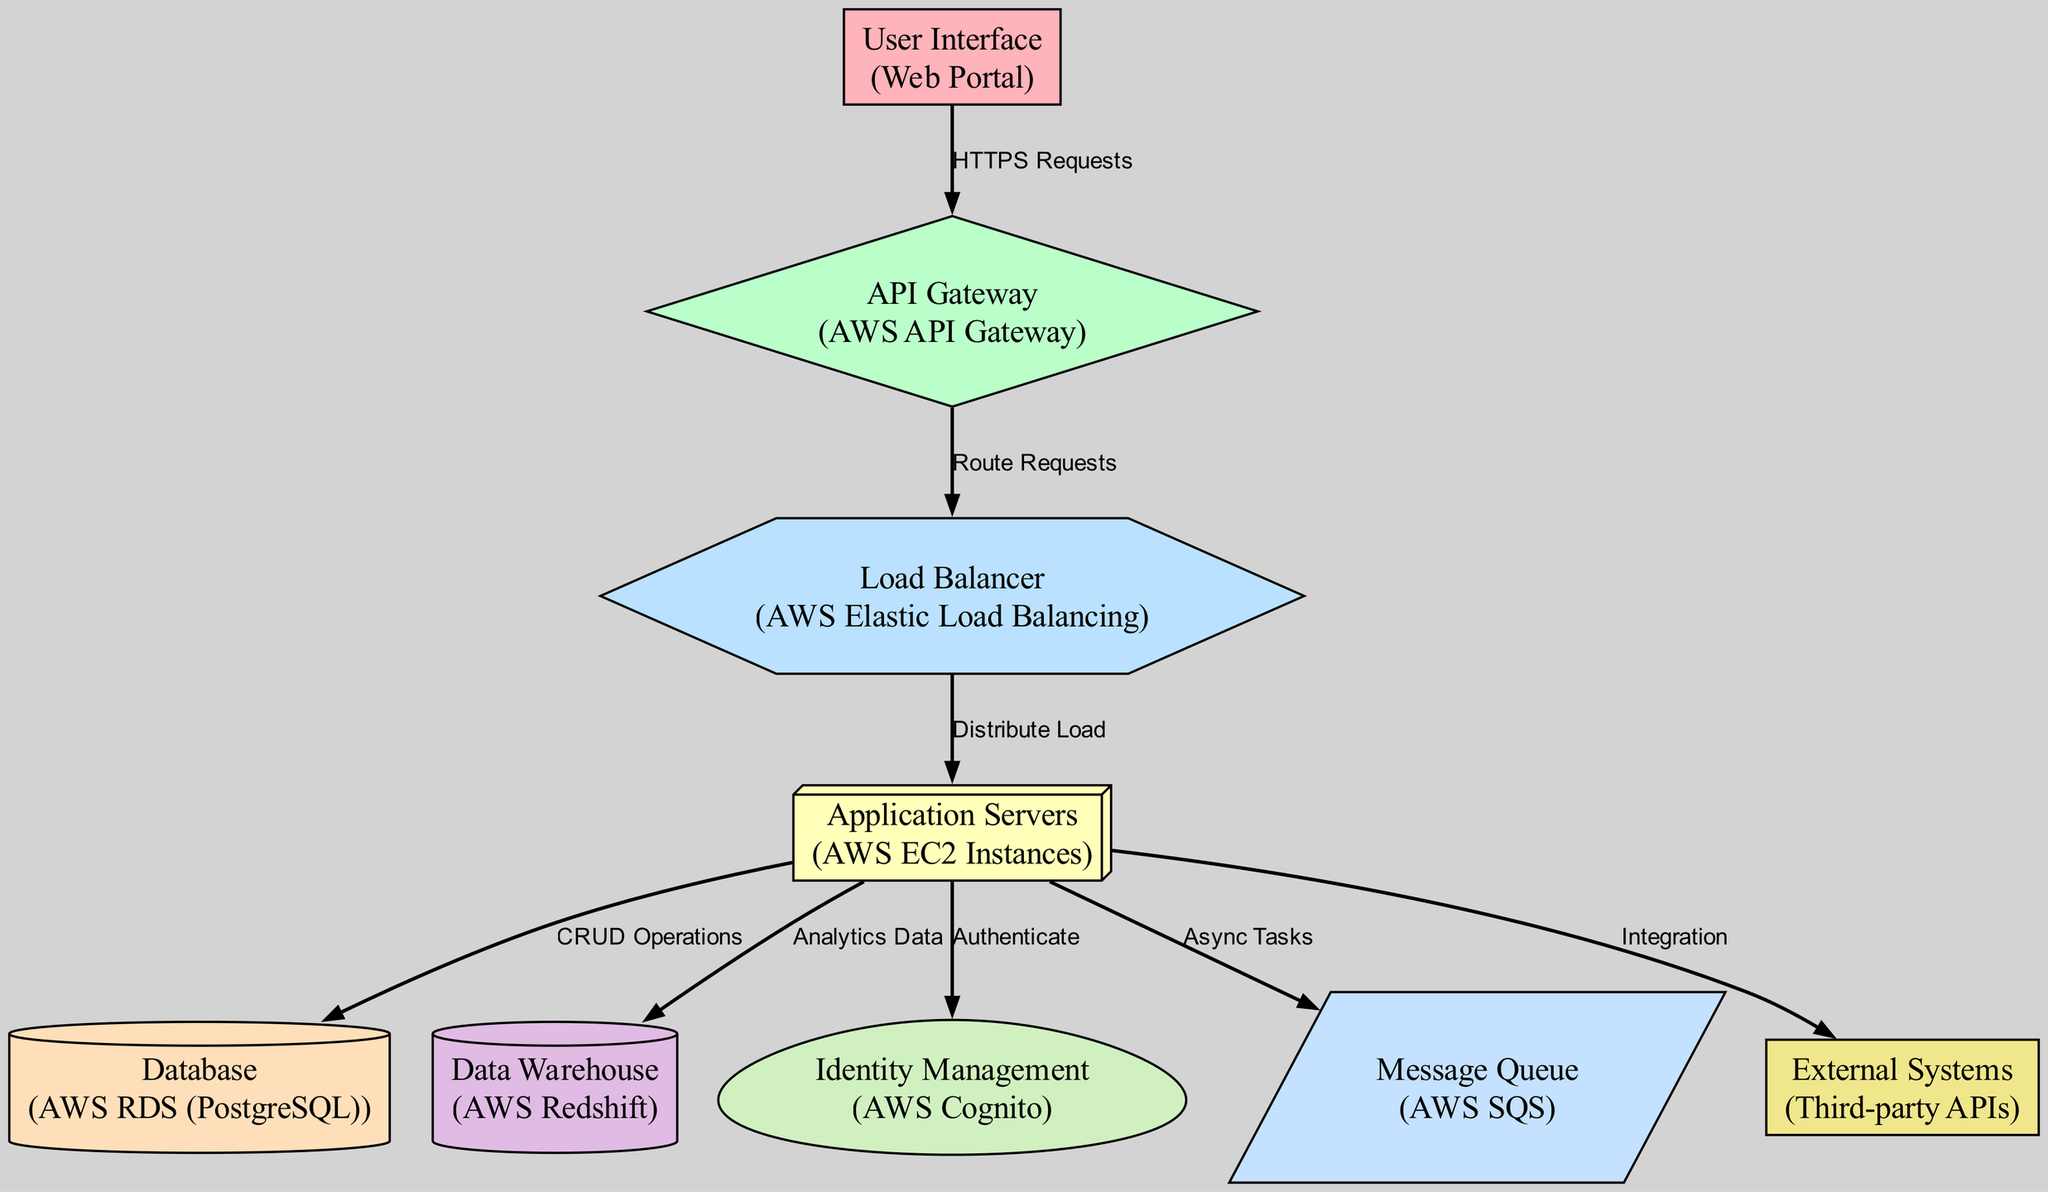What is the type of the first node? The first node is labeled "User Interface" and its type is "Web Portal".
Answer: Web Portal How many edges are there in the diagram? By counting the edges listed, there are a total of 8 edges connecting various nodes in the diagram.
Answer: 8 What is the relationship between the "API Gateway" and "Load Balancer"? The "API Gateway" routes requests to the "Load Balancer", indicating a direct flow of information between these two nodes.
Answer: Route Requests Which node is responsible for "CRUD Operations"? The "Application Servers" node interacts with the "Database" node to perform CRUD (Create, Read, Update, Delete) operations.
Answer: Application Servers What type of integration does the "Application Servers" have with "External Systems"? The "Application Servers" node integrates with "External Systems" through labeled connections indicating integration.
Answer: Integration Describe the flow of data from the "Application Servers" to the "Data Warehouse". The "Application Servers" send "Analytics Data" to the "Data Warehouse", illustrating that data collected from operations is stored in the data warehouse for analysis.
Answer: Analytics Data What node handles authentication in this architecture? The "Identity Management" node, described as "AWS Cognito", is responsible for authenticating users in this system architecture.
Answer: AWS Cognito What is the purpose of the "Message Queue" in the diagram? The "Message Queue" node labeled "AWS SQS" is used for handling "Async Tasks", indicating it supports asynchronous processing within the system.
Answer: Async Tasks Which component primarily serves the user interface? The "User Interface" node connects to the "API Gateway", acting as the primary component that serves user requests through the web portal.
Answer: User Interface 